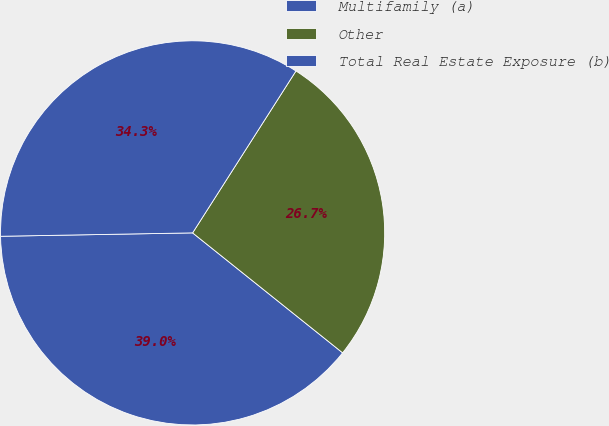Convert chart. <chart><loc_0><loc_0><loc_500><loc_500><pie_chart><fcel>Multifamily (a)<fcel>Other<fcel>Total Real Estate Exposure (b)<nl><fcel>38.98%<fcel>26.69%<fcel>34.32%<nl></chart> 